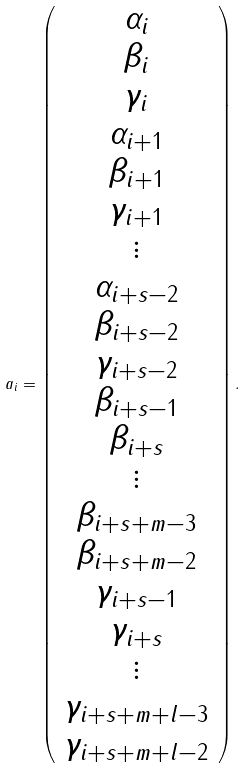<formula> <loc_0><loc_0><loc_500><loc_500>a _ { i } = \left ( \begin{array} { c } \alpha _ { i } \\ \beta _ { i } \\ \gamma _ { i } \\ \alpha _ { i + 1 } \\ \beta _ { i + 1 } \\ \gamma _ { i + 1 } \\ \vdots \\ \alpha _ { i + s - 2 } \\ \beta _ { i + s - 2 } \\ \gamma _ { i + s - 2 } \\ \beta _ { i + s - 1 } \\ \beta _ { i + s } \\ \vdots \\ \beta _ { i + s + m - 3 } \\ \beta _ { i + s + m - 2 } \\ \gamma _ { i + s - 1 } \\ \gamma _ { i + s } \\ \vdots \\ \gamma _ { i + s + m + l - 3 } \\ \gamma _ { i + s + m + l - 2 } \end{array} \right ) .</formula> 